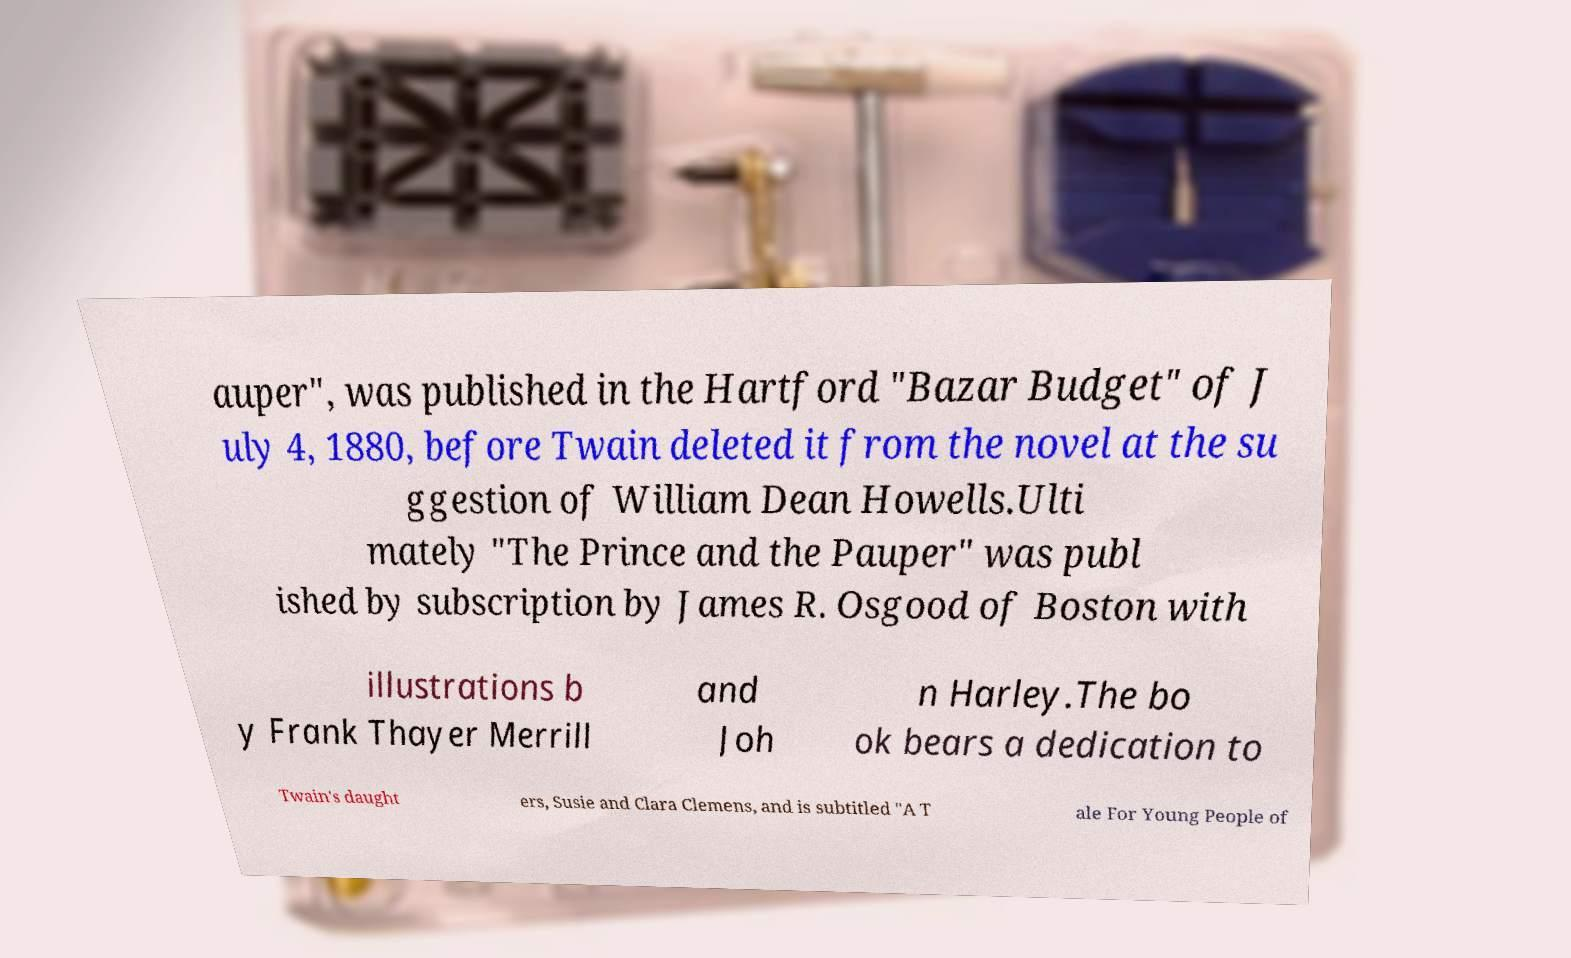Could you assist in decoding the text presented in this image and type it out clearly? auper", was published in the Hartford "Bazar Budget" of J uly 4, 1880, before Twain deleted it from the novel at the su ggestion of William Dean Howells.Ulti mately "The Prince and the Pauper" was publ ished by subscription by James R. Osgood of Boston with illustrations b y Frank Thayer Merrill and Joh n Harley.The bo ok bears a dedication to Twain's daught ers, Susie and Clara Clemens, and is subtitled "A T ale For Young People of 